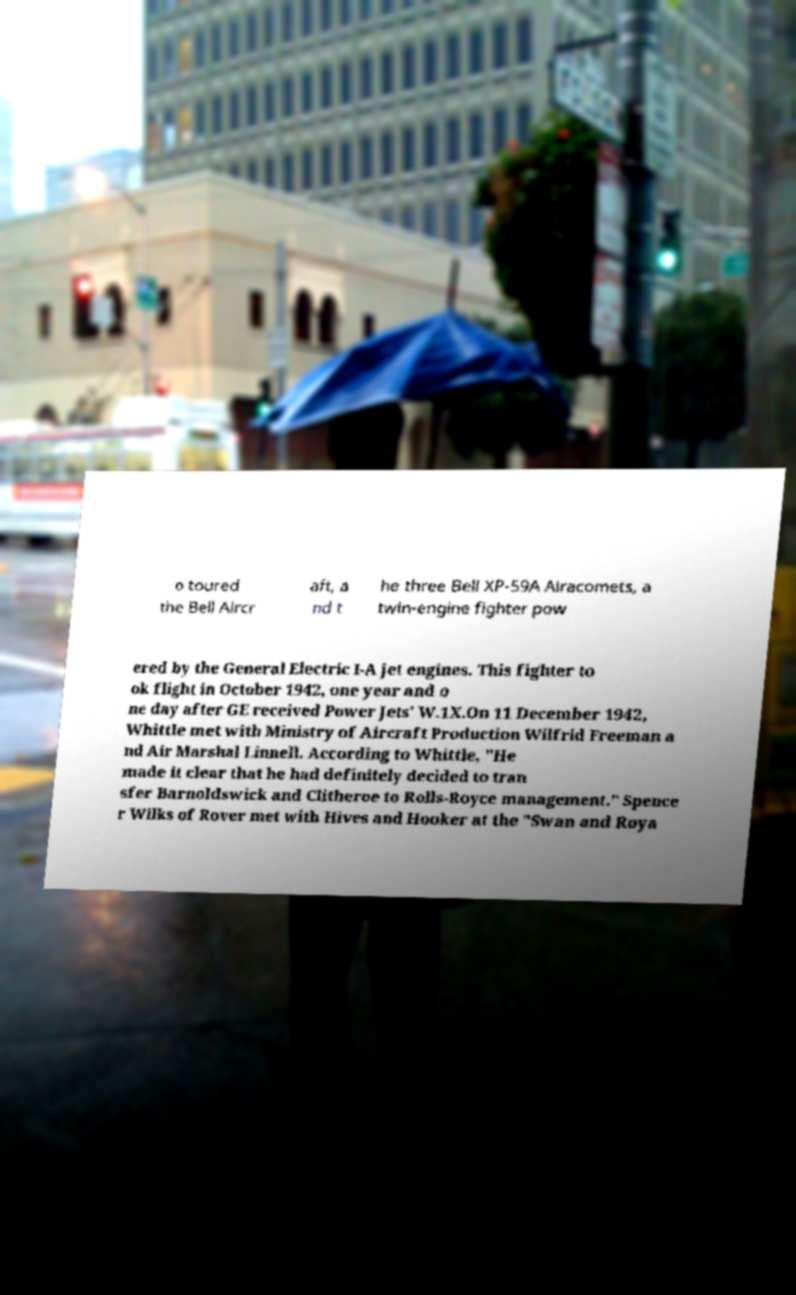For documentation purposes, I need the text within this image transcribed. Could you provide that? o toured the Bell Aircr aft, a nd t he three Bell XP-59A Airacomets, a twin-engine fighter pow ered by the General Electric I-A jet engines. This fighter to ok flight in October 1942, one year and o ne day after GE received Power Jets' W.1X.On 11 December 1942, Whittle met with Ministry of Aircraft Production Wilfrid Freeman a nd Air Marshal Linnell. According to Whittle, "He made it clear that he had definitely decided to tran sfer Barnoldswick and Clitheroe to Rolls-Royce management." Spence r Wilks of Rover met with Hives and Hooker at the "Swan and Roya 